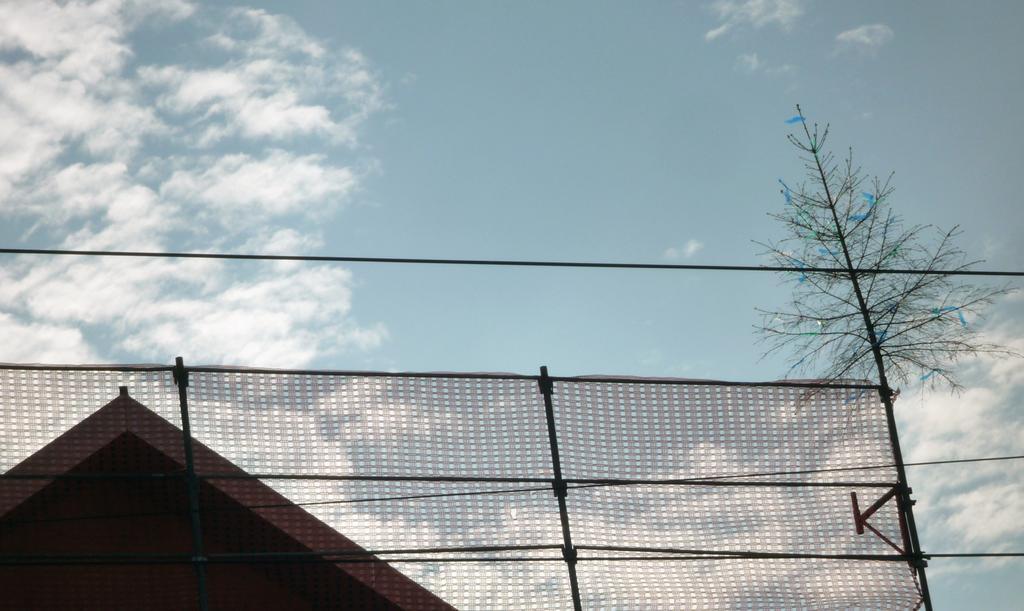Describe this image in one or two sentences. In the foreground of this image, it seems like cloth tied to the rod. In the background, there is a house, tree, sky and the cloud. 